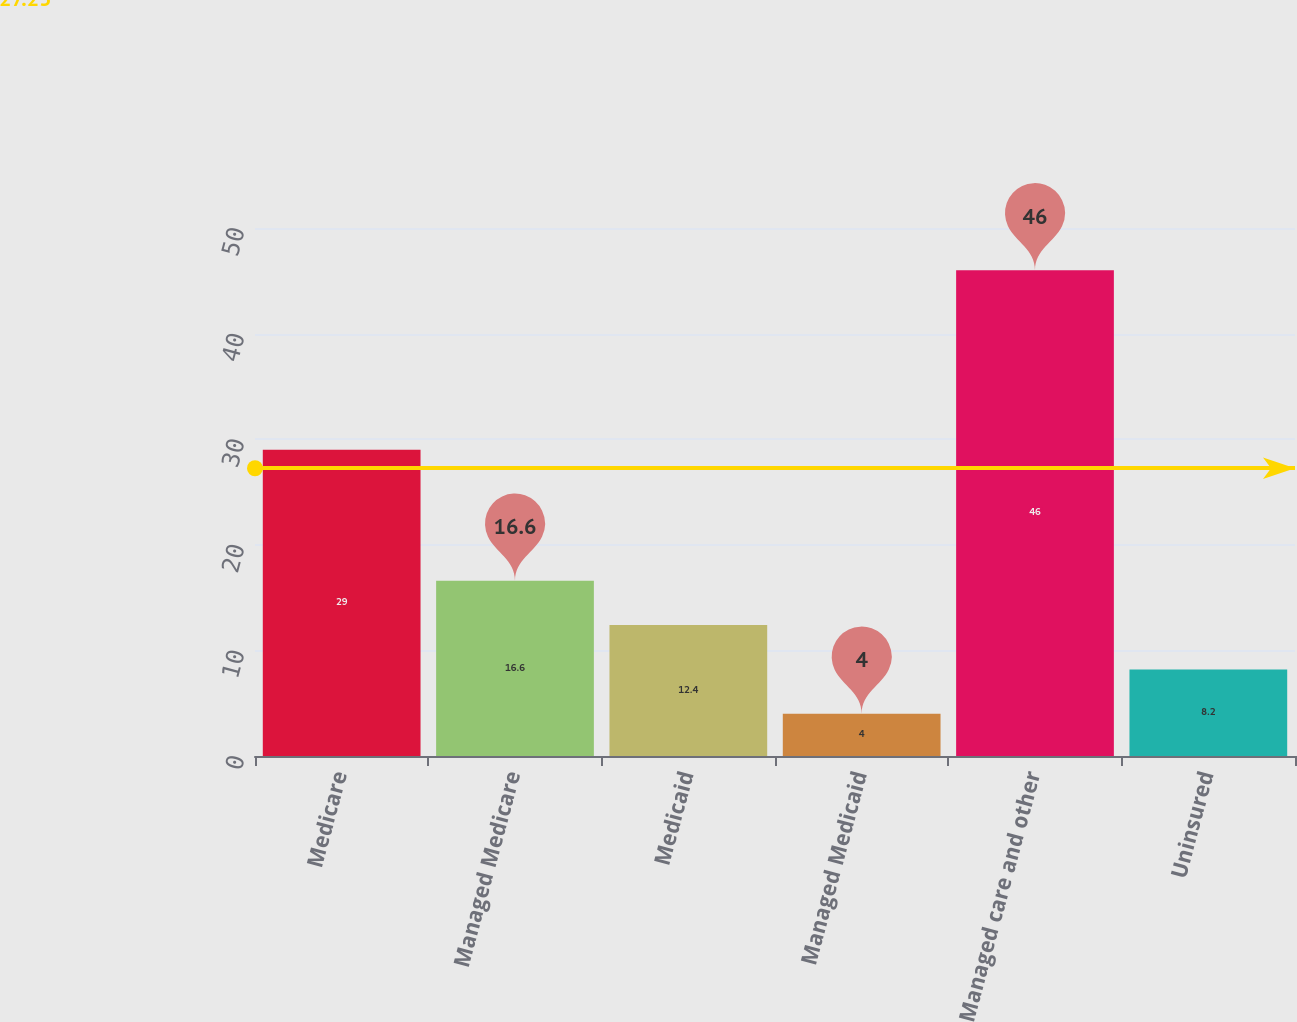Convert chart to OTSL. <chart><loc_0><loc_0><loc_500><loc_500><bar_chart><fcel>Medicare<fcel>Managed Medicare<fcel>Medicaid<fcel>Managed Medicaid<fcel>Managed care and other<fcel>Uninsured<nl><fcel>29<fcel>16.6<fcel>12.4<fcel>4<fcel>46<fcel>8.2<nl></chart> 